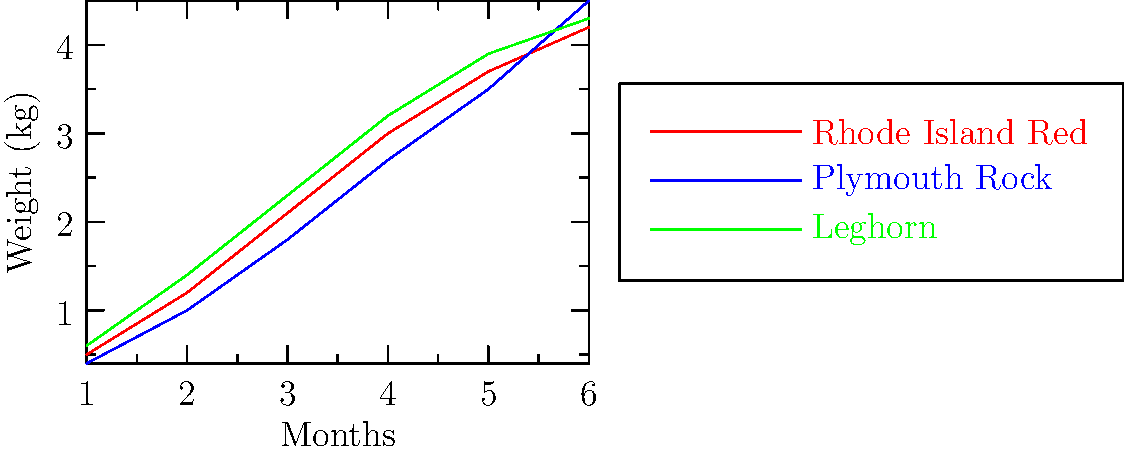As a chicken breeder, you've been tracking the growth rates of three popular breeds over a 6-month period. Based on the line graph, which breed shows the highest growth rate between the 3rd and 4th month, and what is the approximate weight gain during this period? To determine the breed with the highest growth rate between the 3rd and 4th month and calculate the weight gain:

1. Identify the lines for each breed:
   - Red: Rhode Island Red
   - Blue: Plymouth Rock
   - Green: Leghorn

2. Focus on the segment between the 3rd and 4th month for each breed.

3. Calculate the slope (growth rate) for each breed:
   - Rhode Island Red: (3.0 - 2.1) = 0.9 kg
   - Plymouth Rock: (2.7 - 1.8) = 0.9 kg
   - Leghorn: (3.2 - 2.3) = 0.9 kg

4. Compare the slopes:
   All breeds show the same growth rate of 0.9 kg during this period.

5. Since the growth rates are equal, we need to consider which breed gained the most weight:
   - Leghorn starts at 2.3 kg and ends at 3.2 kg, gaining 0.9 kg.
   - This is the highest end weight among the three breeds.

Therefore, the Leghorn breed shows the highest growth rate (tied with others) and the highest weight gain between the 3rd and 4th month.
Answer: Leghorn, 0.9 kg 